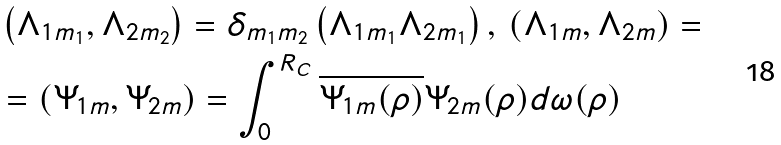<formula> <loc_0><loc_0><loc_500><loc_500>& \left ( \Lambda _ { 1 m _ { 1 } } , \Lambda _ { 2 m _ { 2 } } \right ) = \delta _ { m _ { 1 } m _ { 2 } } \left ( \Lambda _ { 1 m _ { 1 } } \Lambda _ { 2 m _ { 1 } } \right ) , \, \left ( \Lambda _ { 1 m } , \Lambda _ { 2 m } \right ) = \\ & = \left ( \Psi _ { 1 m } , \Psi _ { 2 m } \right ) = \int _ { 0 } ^ { R _ { C } } \overline { \Psi _ { 1 m } ( \rho ) } \Psi _ { 2 m } ( \rho ) d \omega ( \rho )</formula> 